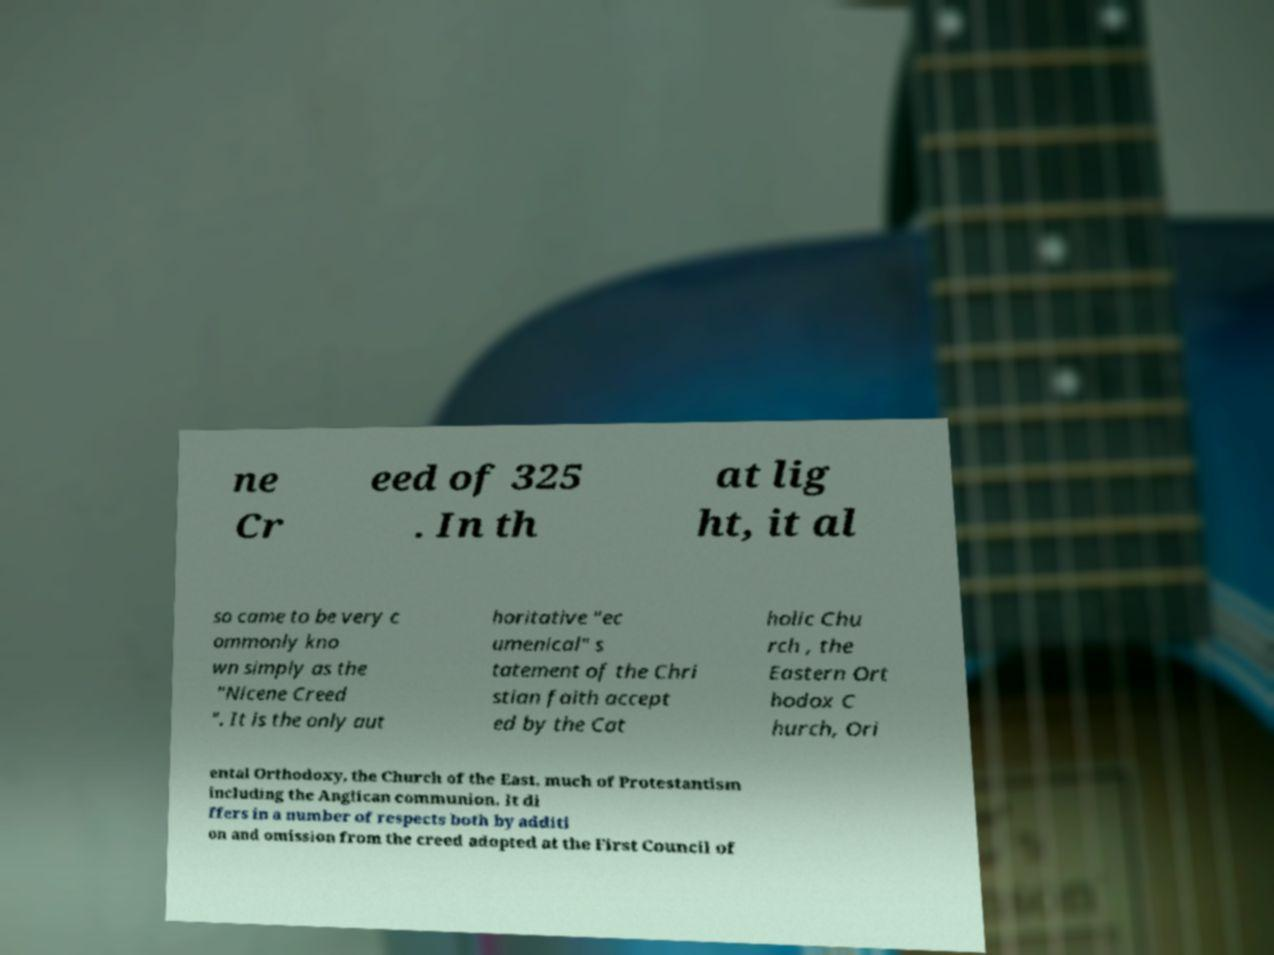Can you read and provide the text displayed in the image?This photo seems to have some interesting text. Can you extract and type it out for me? ne Cr eed of 325 . In th at lig ht, it al so came to be very c ommonly kno wn simply as the "Nicene Creed ". It is the only aut horitative "ec umenical" s tatement of the Chri stian faith accept ed by the Cat holic Chu rch , the Eastern Ort hodox C hurch, Ori ental Orthodoxy, the Church of the East, much of Protestantism including the Anglican communion. It di ffers in a number of respects both by additi on and omission from the creed adopted at the First Council of 